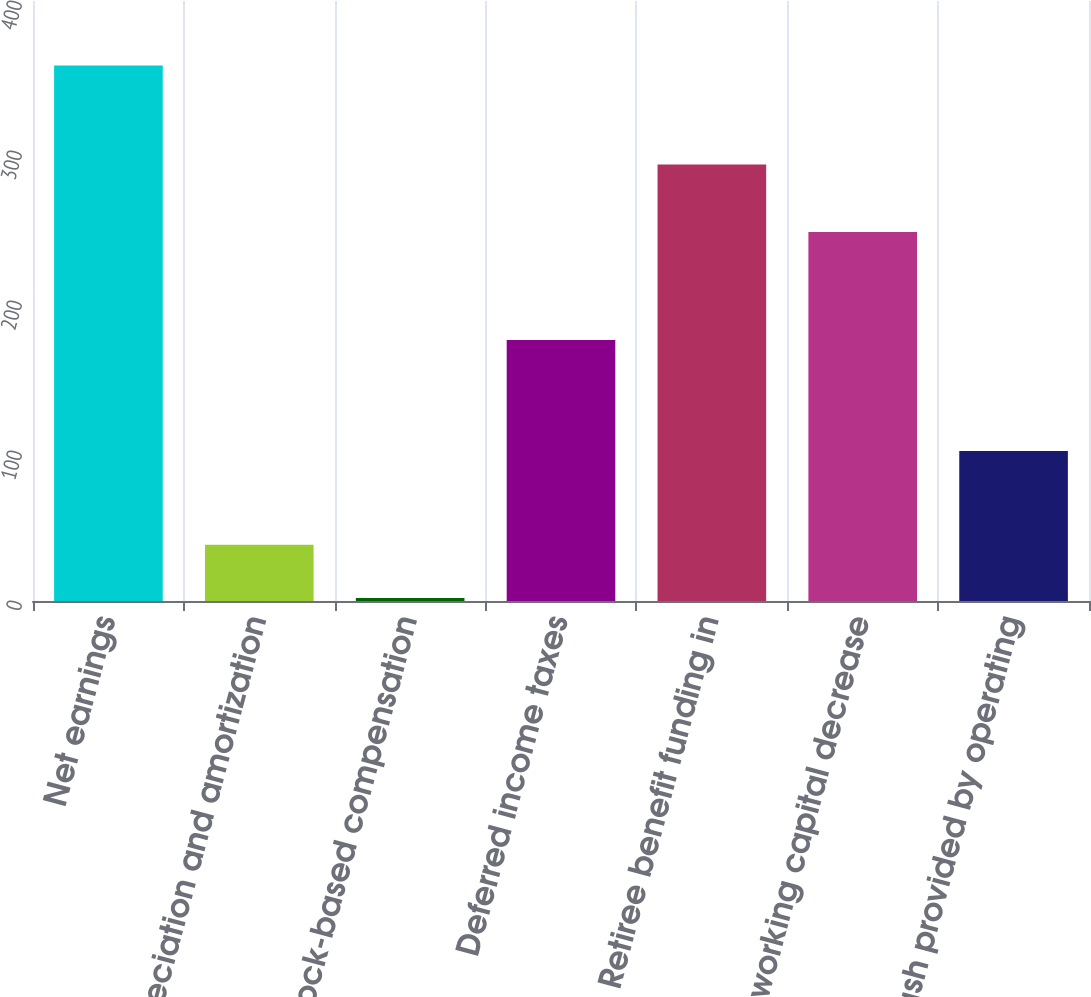Convert chart to OTSL. <chart><loc_0><loc_0><loc_500><loc_500><bar_chart><fcel>Net earnings<fcel>Depreciation and amortization<fcel>Stock-based compensation<fcel>Deferred income taxes<fcel>Retiree benefit funding in<fcel>Trade working capital decrease<fcel>Net cash provided by operating<nl><fcel>357<fcel>37.5<fcel>2<fcel>174<fcel>291<fcel>246<fcel>100<nl></chart> 